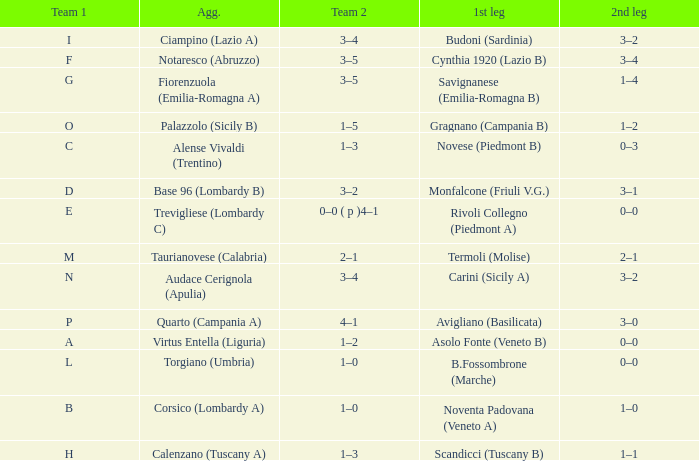What 1st leg has Alense Vivaldi (Trentino) as Agg.? Novese (Piedmont B). 